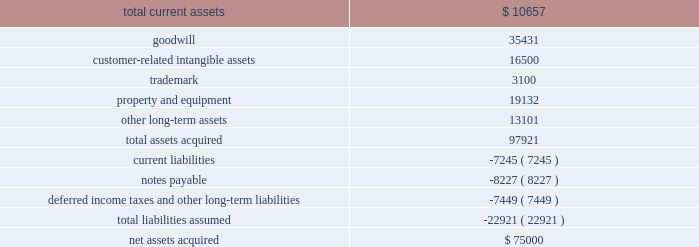Notes to consolidated financial statements 2014 ( continued ) ucs .
As of may 31 , 2009 , $ 55.0 million of the purchase price was held in escrow ( the 201cescrow account 201d ) .
Prior to our acquisition of ucs , the former parent company of ucs pledged the company 2019s stock as collateral for a third party loan ( 201cthe loan 201d ) that matures on september 24 , 2009 .
Upon repayment of this loan , the stock will be released to us and $ 35.0 million of the purchase price will be released to the seller .
The remaining $ 20.0 million will remain in escrow until january 1 , 2013 , to satisfy any liabilities discovered post-closing that existed at the purchase date .
The purpose of this acquisition was to establish an acquiring presence in the russian market and a foundation for other direct acquiring opportunities in central and eastern europe .
The purchase price was determined by analyzing the historical and prospective financial statements and applying relevant purchase price multiples .
This business acquisition was not significant to our consolidated financial statements and accordingly , we have not provided pro forma information relating to this acquisition .
Upon acquisition of ucs global payments assumed an indirect guarantee of the loan .
In the event of a default by the third-party debtor , we would be required to transfer all of the shares of ucs to the trustee or pay the amount outstanding under the loan .
At may 31 , 2009 the maximum potential amount of future payments under the guarantee was $ 44.1 million which represents the total outstanding under the loan , consisting of $ 21.8 million due and paid on june 24 , 2009 and $ 22.3 million due on september 24 , 2009 .
Should the third-party debtor default on the final payment , global payments would pay the total amount outstanding and seek to be reimbursed for any payments made from the $ 55 million held in the escrow account .
We did not record an obligation for this guarantee because we determined that the fair value of the guarantee is de minimis .
The table summarizes the preliminary purchase price allocation ( in thousands ) : .
All of the goodwill associated with the acquisition is non-deductible for tax purposes .
The customer-related intangible assets have amortization periods of 9 to 15 years .
The trademark has an amortization period of 10 years .
Global payments asia-pacific philippines incorporated on september 4 , 2008 , global payments asia-pacific , limited ( 201cgpap 201d ) , the entity through which we conduct our merchant acquiring business in the asia-pacific region , indirectly acquired global payments asia- pacific philippines incorporated ( 201cgpap philippines 201d ) , a newly formed company into which hsbc asia pacific contributed its merchant acquiring business in the philippines .
We own 56% ( 56 % ) of gpap and hsbc asia pacific .
What will be the amortization cost in thousands each year for the trademark? 
Computations: (3100 / 10)
Answer: 310.0. 